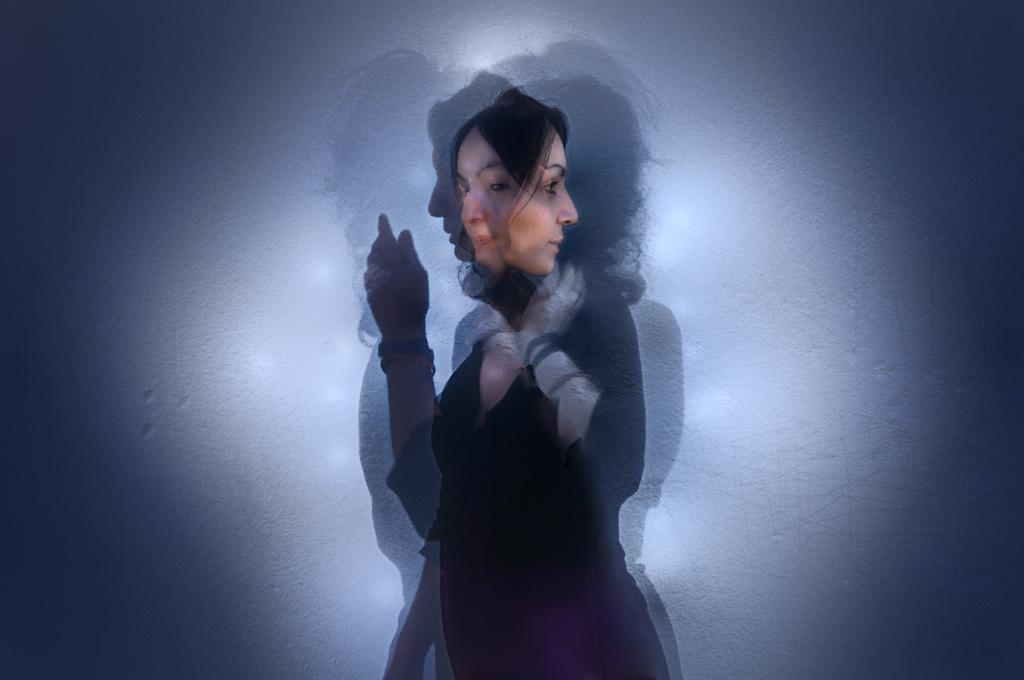In one or two sentences, can you explain what this image depicts? In this edited image, we can see a person on the blue background. 